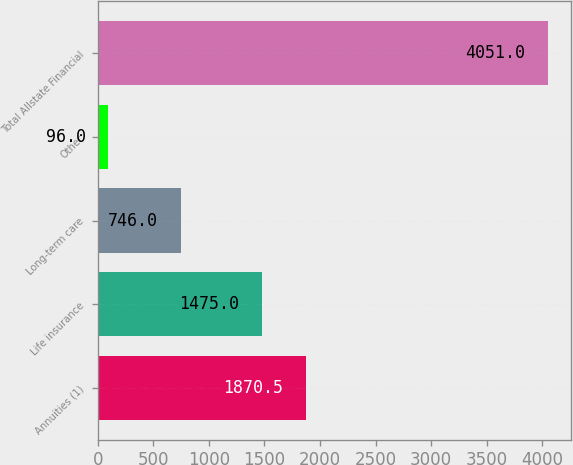<chart> <loc_0><loc_0><loc_500><loc_500><bar_chart><fcel>Annuities (1)<fcel>Life insurance<fcel>Long-term care<fcel>Other<fcel>Total Allstate Financial<nl><fcel>1870.5<fcel>1475<fcel>746<fcel>96<fcel>4051<nl></chart> 